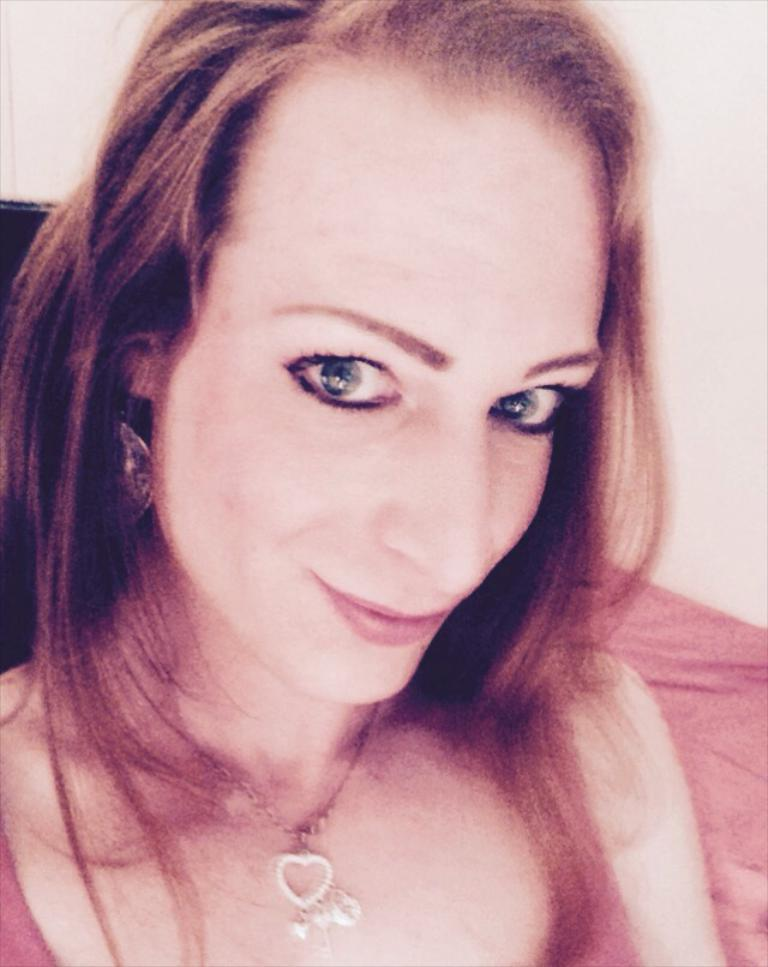Who is present in the image? There is a woman in the picture. What is the woman doing in the image? The woman is smiling. What accessory is the woman wearing in the image? The woman is wearing a necklace. What type of knee can be seen in the image? There is no knee visible in the image; it features a woman who is smiling and wearing a necklace. 